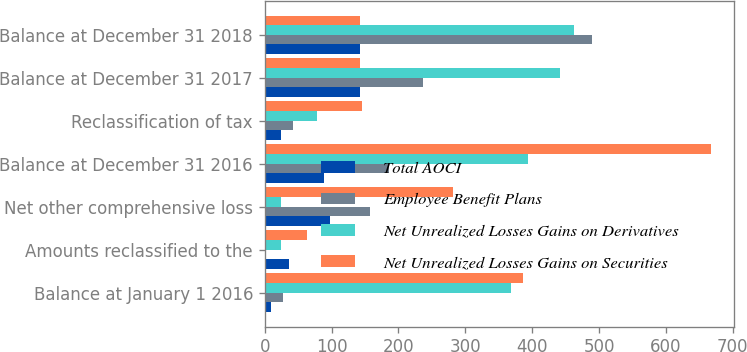Convert chart to OTSL. <chart><loc_0><loc_0><loc_500><loc_500><stacked_bar_chart><ecel><fcel>Balance at January 1 2016<fcel>Amounts reclassified to the<fcel>Net other comprehensive loss<fcel>Balance at December 31 2016<fcel>Reclassification of tax<fcel>Balance at December 31 2017<fcel>Balance at December 31 2018<nl><fcel>Total AOCI<fcel>10<fcel>36<fcel>98<fcel>88<fcel>25<fcel>143<fcel>143<nl><fcel>Employee Benefit Plans<fcel>28<fcel>2<fcel>158<fcel>186<fcel>42<fcel>236<fcel>490<nl><fcel>Net Unrealized Losses Gains on Derivatives<fcel>369<fcel>25<fcel>25<fcel>394<fcel>78<fcel>441<fcel>463<nl><fcel>Net Unrealized Losses Gains on Securities<fcel>387<fcel>63<fcel>281<fcel>668<fcel>145<fcel>143<fcel>143<nl></chart> 